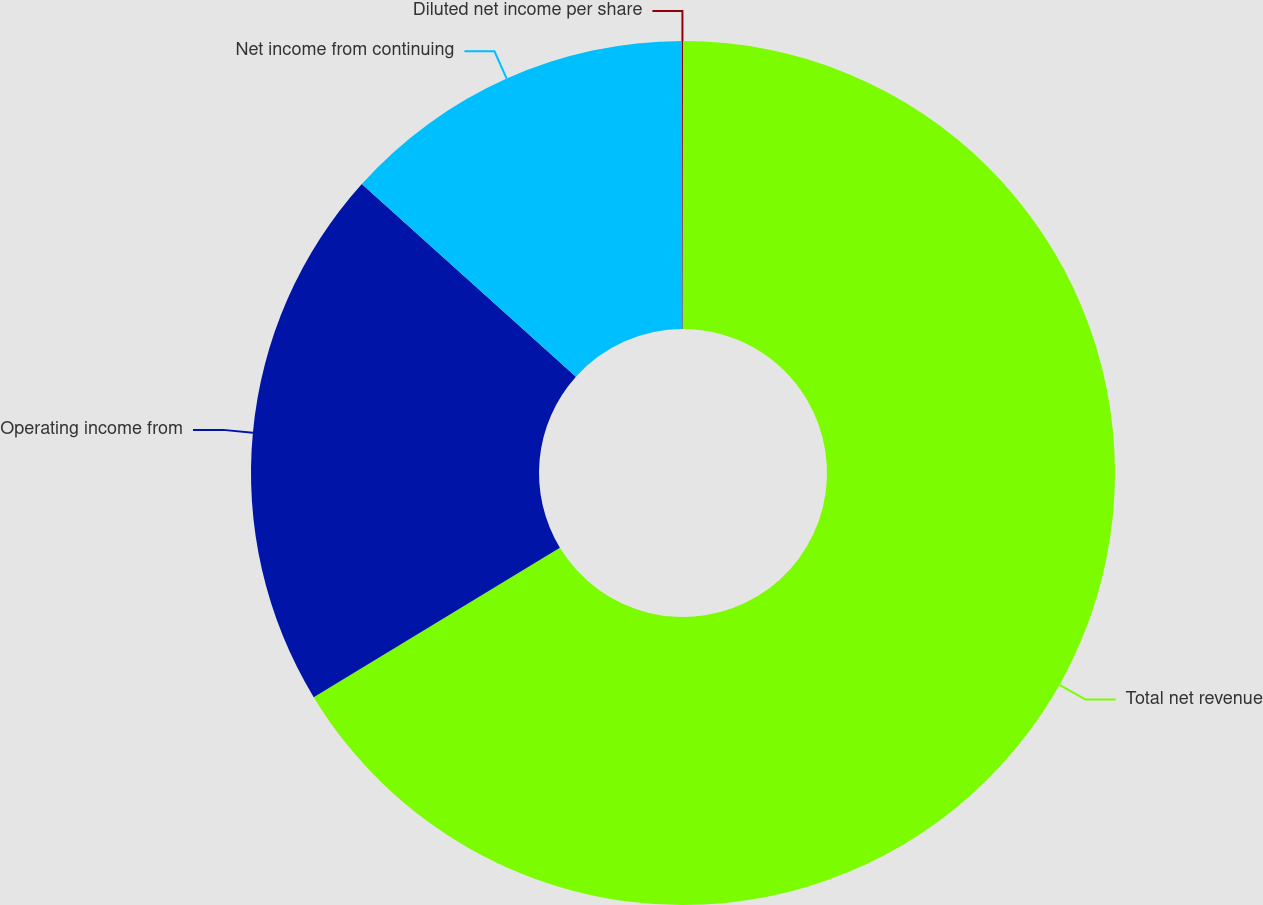<chart> <loc_0><loc_0><loc_500><loc_500><pie_chart><fcel>Total net revenue<fcel>Operating income from<fcel>Net income from continuing<fcel>Diluted net income per share<nl><fcel>66.31%<fcel>20.34%<fcel>13.3%<fcel>0.04%<nl></chart> 